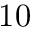Convert formula to latex. <formula><loc_0><loc_0><loc_500><loc_500>1 0</formula> 